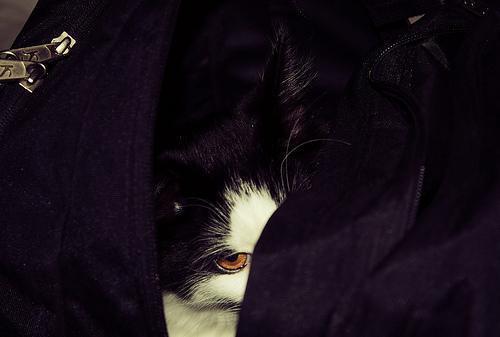How many cats are in the picture?
Give a very brief answer. 1. 